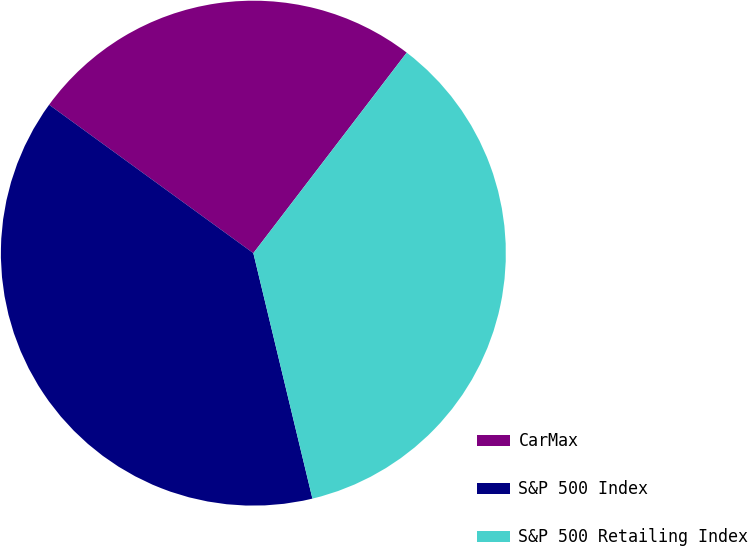<chart> <loc_0><loc_0><loc_500><loc_500><pie_chart><fcel>CarMax<fcel>S&P 500 Index<fcel>S&P 500 Retailing Index<nl><fcel>25.39%<fcel>38.76%<fcel>35.85%<nl></chart> 